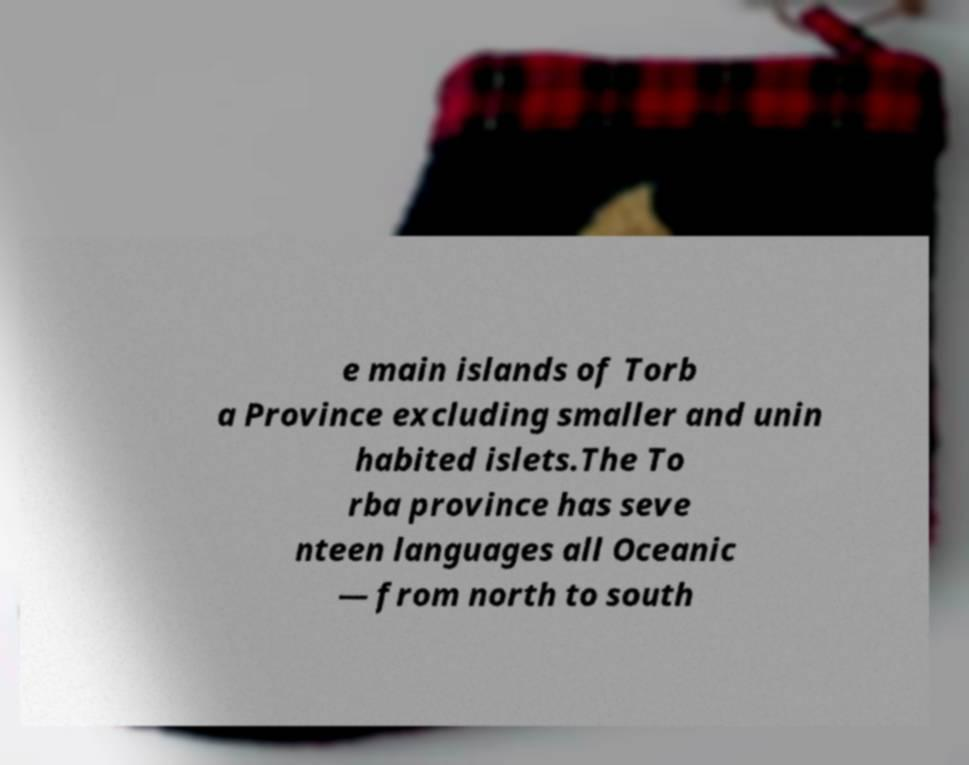For documentation purposes, I need the text within this image transcribed. Could you provide that? e main islands of Torb a Province excluding smaller and unin habited islets.The To rba province has seve nteen languages all Oceanic — from north to south 